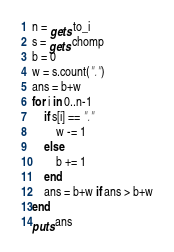Convert code to text. <code><loc_0><loc_0><loc_500><loc_500><_Ruby_>n = gets.to_i
s = gets.chomp
b = 0
w = s.count(".")
ans = b+w
for i in 0..n-1
    if s[i] == "."
        w -= 1
    else
        b += 1
    end
    ans = b+w if ans > b+w
end
puts ans</code> 